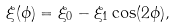Convert formula to latex. <formula><loc_0><loc_0><loc_500><loc_500>\xi ( \phi ) = \xi _ { 0 } - \xi _ { 1 } \cos ( 2 \phi ) ,</formula> 